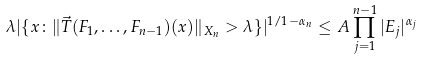<formula> <loc_0><loc_0><loc_500><loc_500>\lambda | \{ x \colon \| \vec { T } ( F _ { 1 } , \dots , F _ { n - 1 } ) ( x ) \| _ { X _ { n } } > \lambda \} | ^ { 1 / { 1 - \alpha _ { n } } } \leq A \prod _ { j = 1 } ^ { n - 1 } | E _ { j } | ^ { \alpha _ { j } }</formula> 